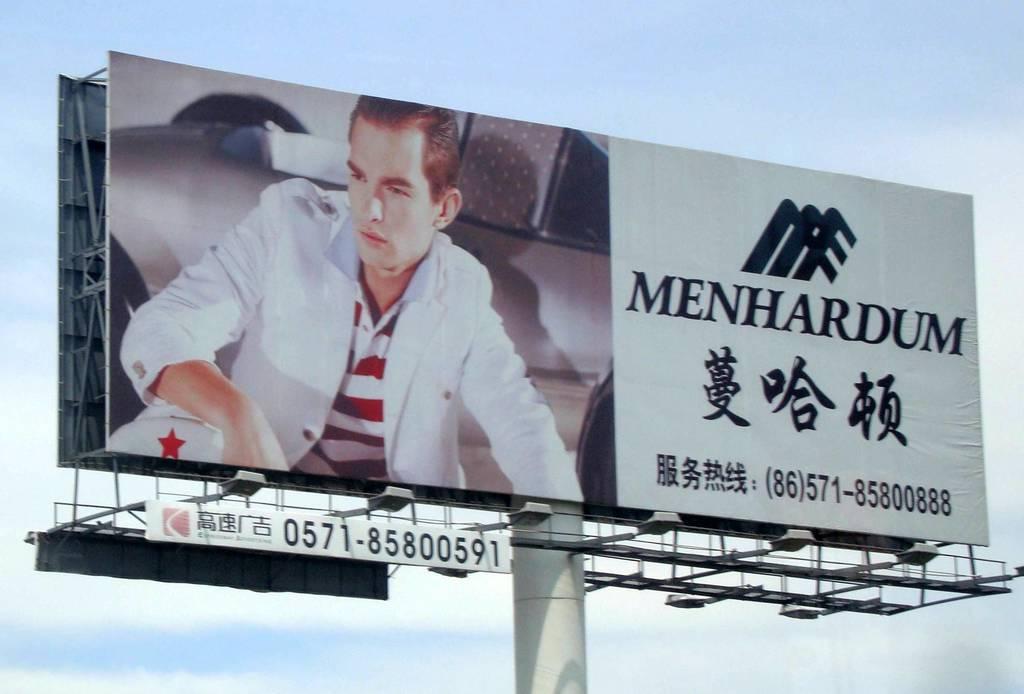What phone number on the ad?
Offer a terse response. (86)571-85800888. 